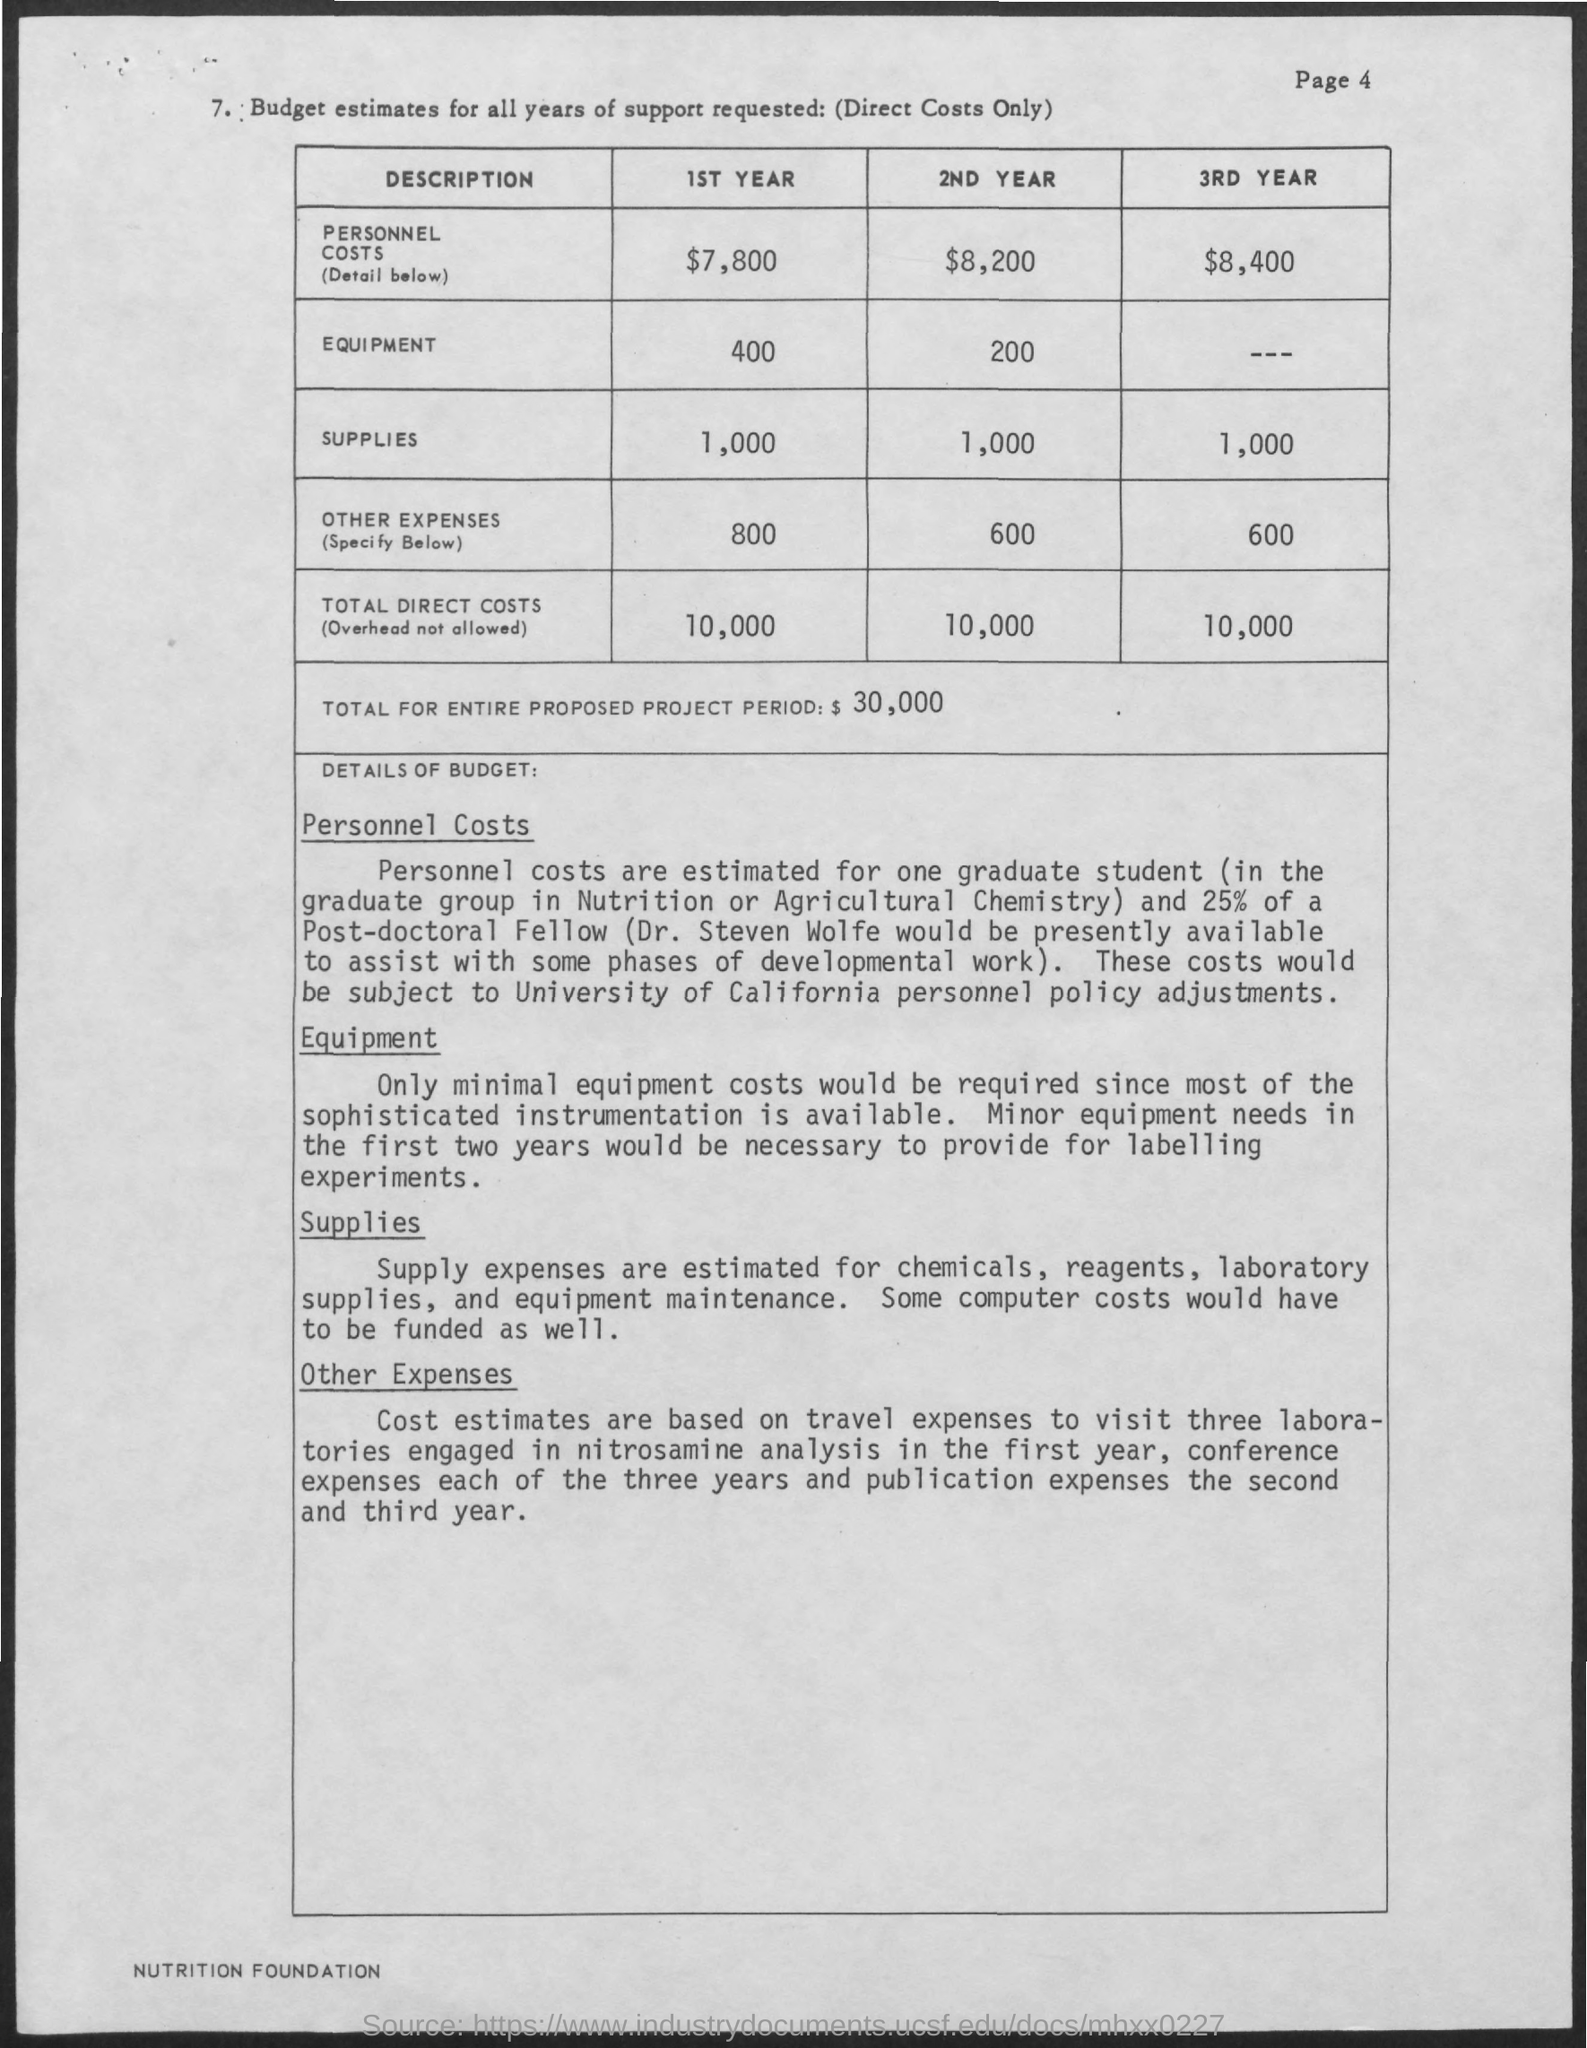Highlight a few significant elements in this photo. The equipment costs for the second year of operation are estimated to be $200,000. The personnel costs for the second year are estimated to be $8,200. The total direct costs for the first year are estimated to be 10,000. The total direct costs for the second year are estimated to be 10,000. The amount of supplies required for the second year of the project is estimated to be 1,000. 